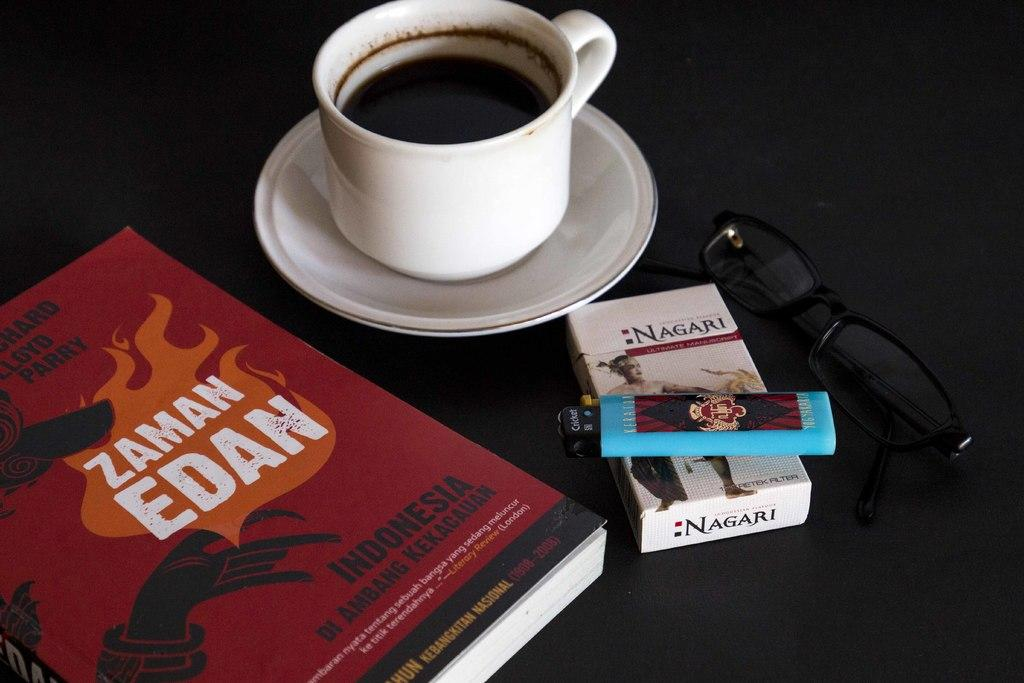<image>
Offer a succinct explanation of the picture presented. A pack of Nagari brand cigarettes with a lighter, glasses, a book and a cup of coffee on the side. 